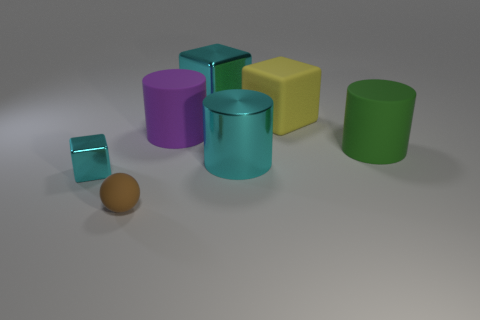Is there anything else that has the same size as the matte ball?
Ensure brevity in your answer.  Yes. Is the size of the rubber cylinder that is in front of the purple rubber object the same as the small ball?
Keep it short and to the point. No. There is a cyan object that is behind the green cylinder; what is its material?
Keep it short and to the point. Metal. Is there any other thing that has the same shape as the small brown object?
Your answer should be compact. No. How many metallic things are either yellow spheres or cyan cylinders?
Give a very brief answer. 1. Are there fewer brown rubber objects on the right side of the tiny cyan thing than tiny things?
Your response must be concise. Yes. There is a cyan thing that is to the left of the object behind the large block right of the cyan metal cylinder; what is its shape?
Your answer should be compact. Cube. Do the small rubber object and the metal cylinder have the same color?
Ensure brevity in your answer.  No. Are there more blue metallic things than large purple things?
Your answer should be compact. No. How many other objects are the same material as the big green object?
Provide a succinct answer. 3. 